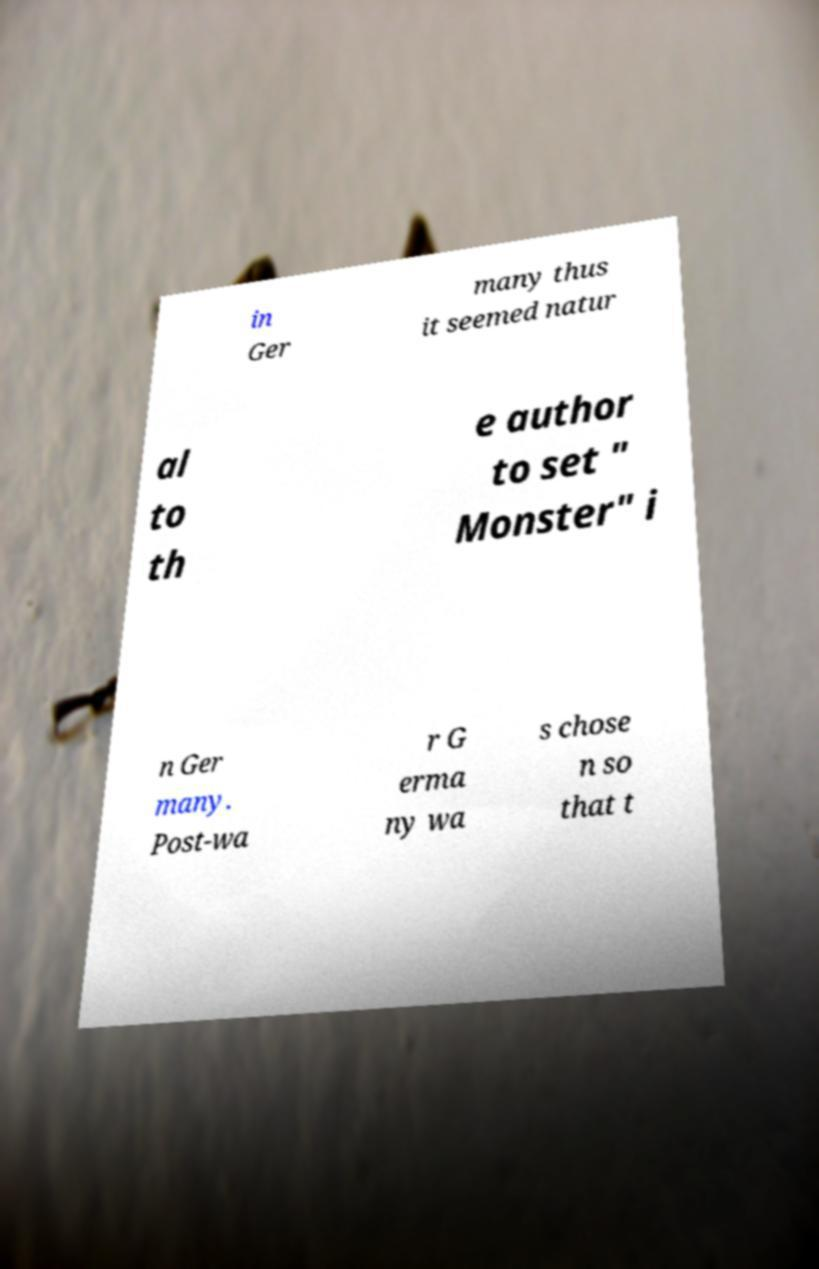Please identify and transcribe the text found in this image. in Ger many thus it seemed natur al to th e author to set " Monster" i n Ger many. Post-wa r G erma ny wa s chose n so that t 